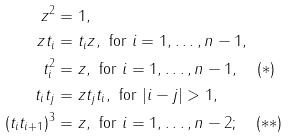<formula> <loc_0><loc_0><loc_500><loc_500>z ^ { 2 } & = 1 , \\ z t _ { i } & = t _ { i } z , \text { for } i = 1 , \dots , n - 1 , \\ t _ { i } ^ { 2 } & = z , \text { for } i = 1 , \dots , n - 1 , \quad ( \ast ) \\ t _ { i } t _ { j } & = z t _ { j } t _ { i } , \text { for } | i - j | > 1 , \\ ( t _ { i } t _ { i + 1 } ) ^ { 3 } & = z , \text { for } i = 1 , \dots , n - 2 ; \quad ( \ast \ast )</formula> 